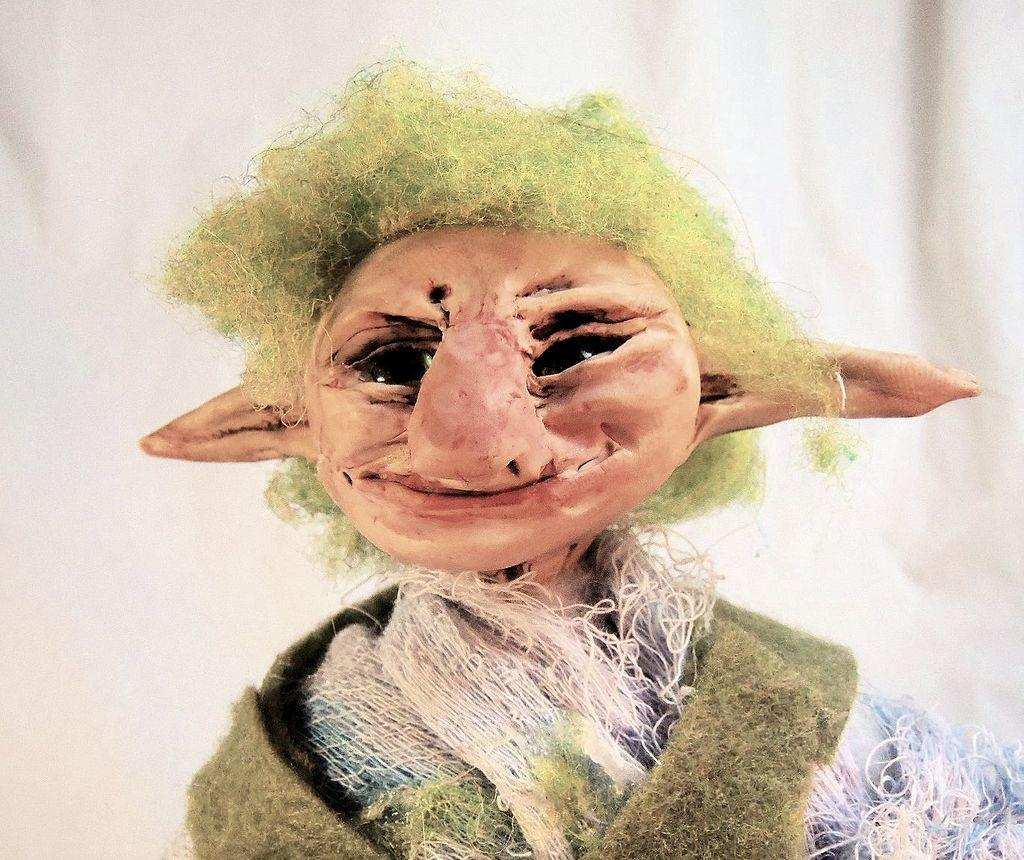What is depicted in the painting in the image? There is a painting of a man in the image. What distinguishing feature does the man have in the painting? The man has white threads in the painting. What object is also present in the painting? There is a sponge in the painting. What color is the sponge in the painting? The sponge is green in color. What is the color of the background in the painting? The background of the painting is white. What might the background represent in the painting? The background might be a wall. How many eggs are present in the painting? There are no eggs depicted in the painting; it features a man with white threads and a green sponge against a white background. What type of fish can be seen swimming in the background of the painting? There are no fish present in the painting; the background is a solid white color. 